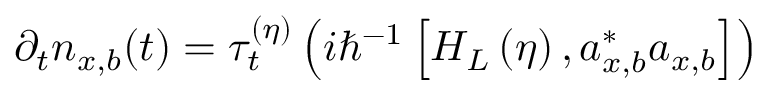Convert formula to latex. <formula><loc_0><loc_0><loc_500><loc_500>\partial _ { t } n _ { x , b } ( t ) = \tau _ { t } ^ { ( \eta ) } \left ( i \hbar { ^ } { - 1 } \left [ H _ { L } \left ( \eta \right ) , a _ { x , b } ^ { \ast } a _ { x , b } \right ] \right )</formula> 